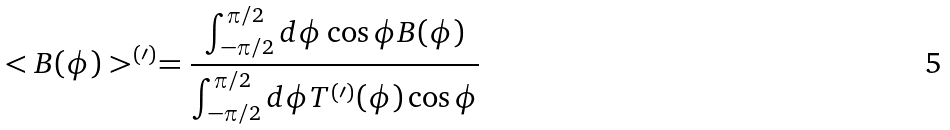Convert formula to latex. <formula><loc_0><loc_0><loc_500><loc_500>< B ( \phi ) > ^ { ( \prime ) } = \frac { \int _ { - \pi / 2 } ^ { \pi / 2 } d \phi \cos \phi B ( \phi ) } { \int _ { - \pi / 2 } ^ { \pi / 2 } d \phi T ^ { ( \prime ) } ( \phi ) \cos \phi }</formula> 